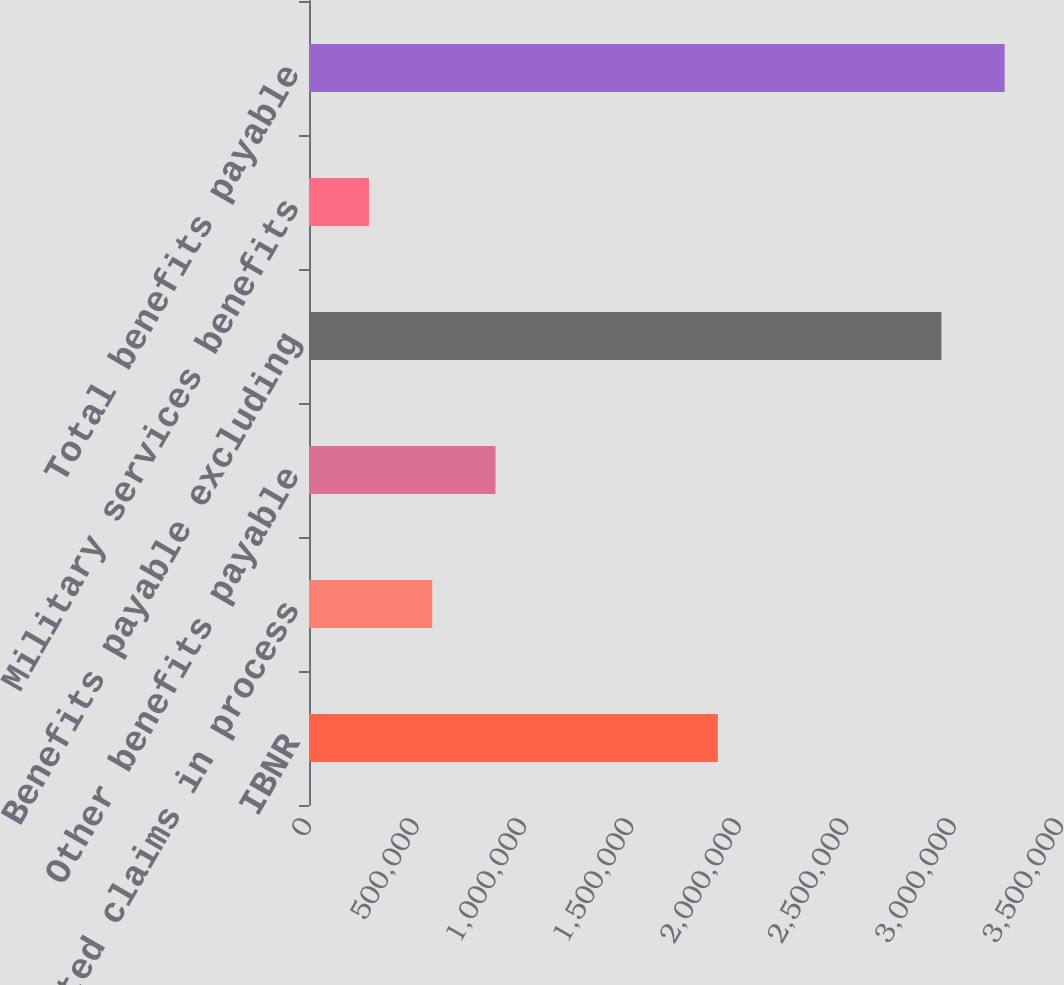<chart> <loc_0><loc_0><loc_500><loc_500><bar_chart><fcel>IBNR<fcel>Reported claims in process<fcel>Other benefits payable<fcel>Benefits payable excluding<fcel>Military services benefits<fcel>Total benefits payable<nl><fcel>1.9027e+06<fcel>573533<fcel>867871<fcel>2.94338e+06<fcel>279195<fcel>3.23772e+06<nl></chart> 